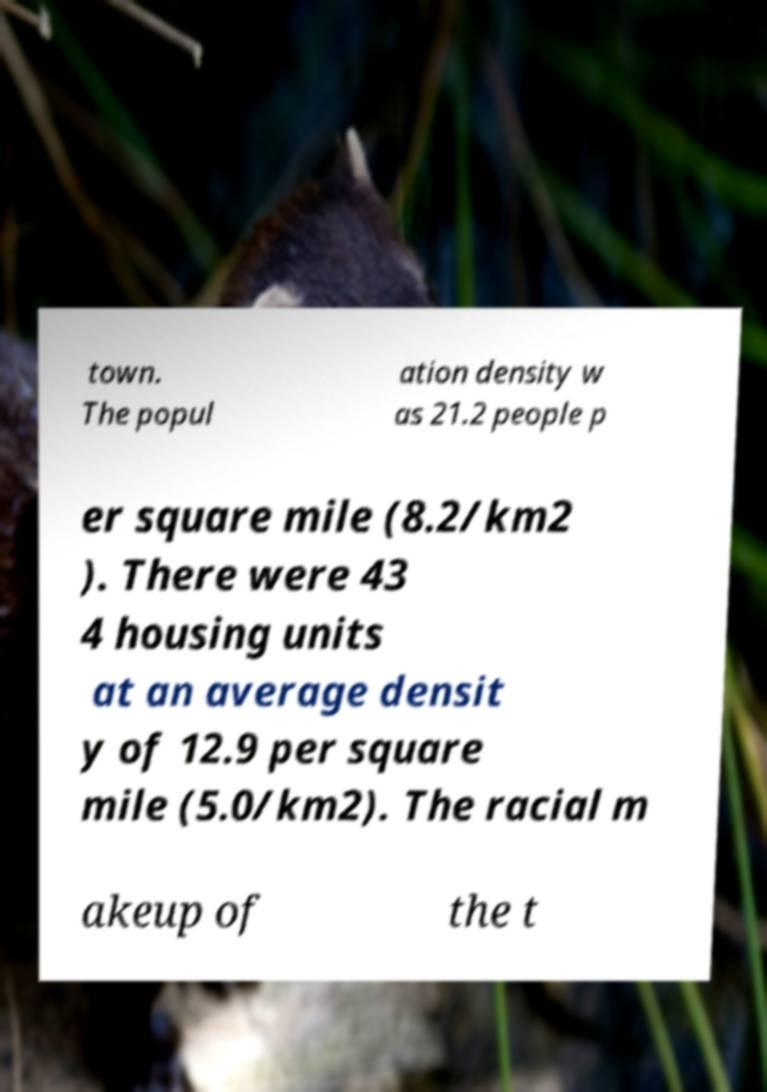Can you read and provide the text displayed in the image?This photo seems to have some interesting text. Can you extract and type it out for me? town. The popul ation density w as 21.2 people p er square mile (8.2/km2 ). There were 43 4 housing units at an average densit y of 12.9 per square mile (5.0/km2). The racial m akeup of the t 